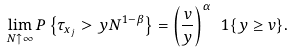<formula> <loc_0><loc_0><loc_500><loc_500>\lim _ { N \uparrow \infty } P \left \{ \tau _ { x _ { j } } > y N ^ { 1 - \beta } \right \} = \left ( \frac { v } y \right ) ^ { \alpha } \ 1 \{ y \geq v \} .</formula> 